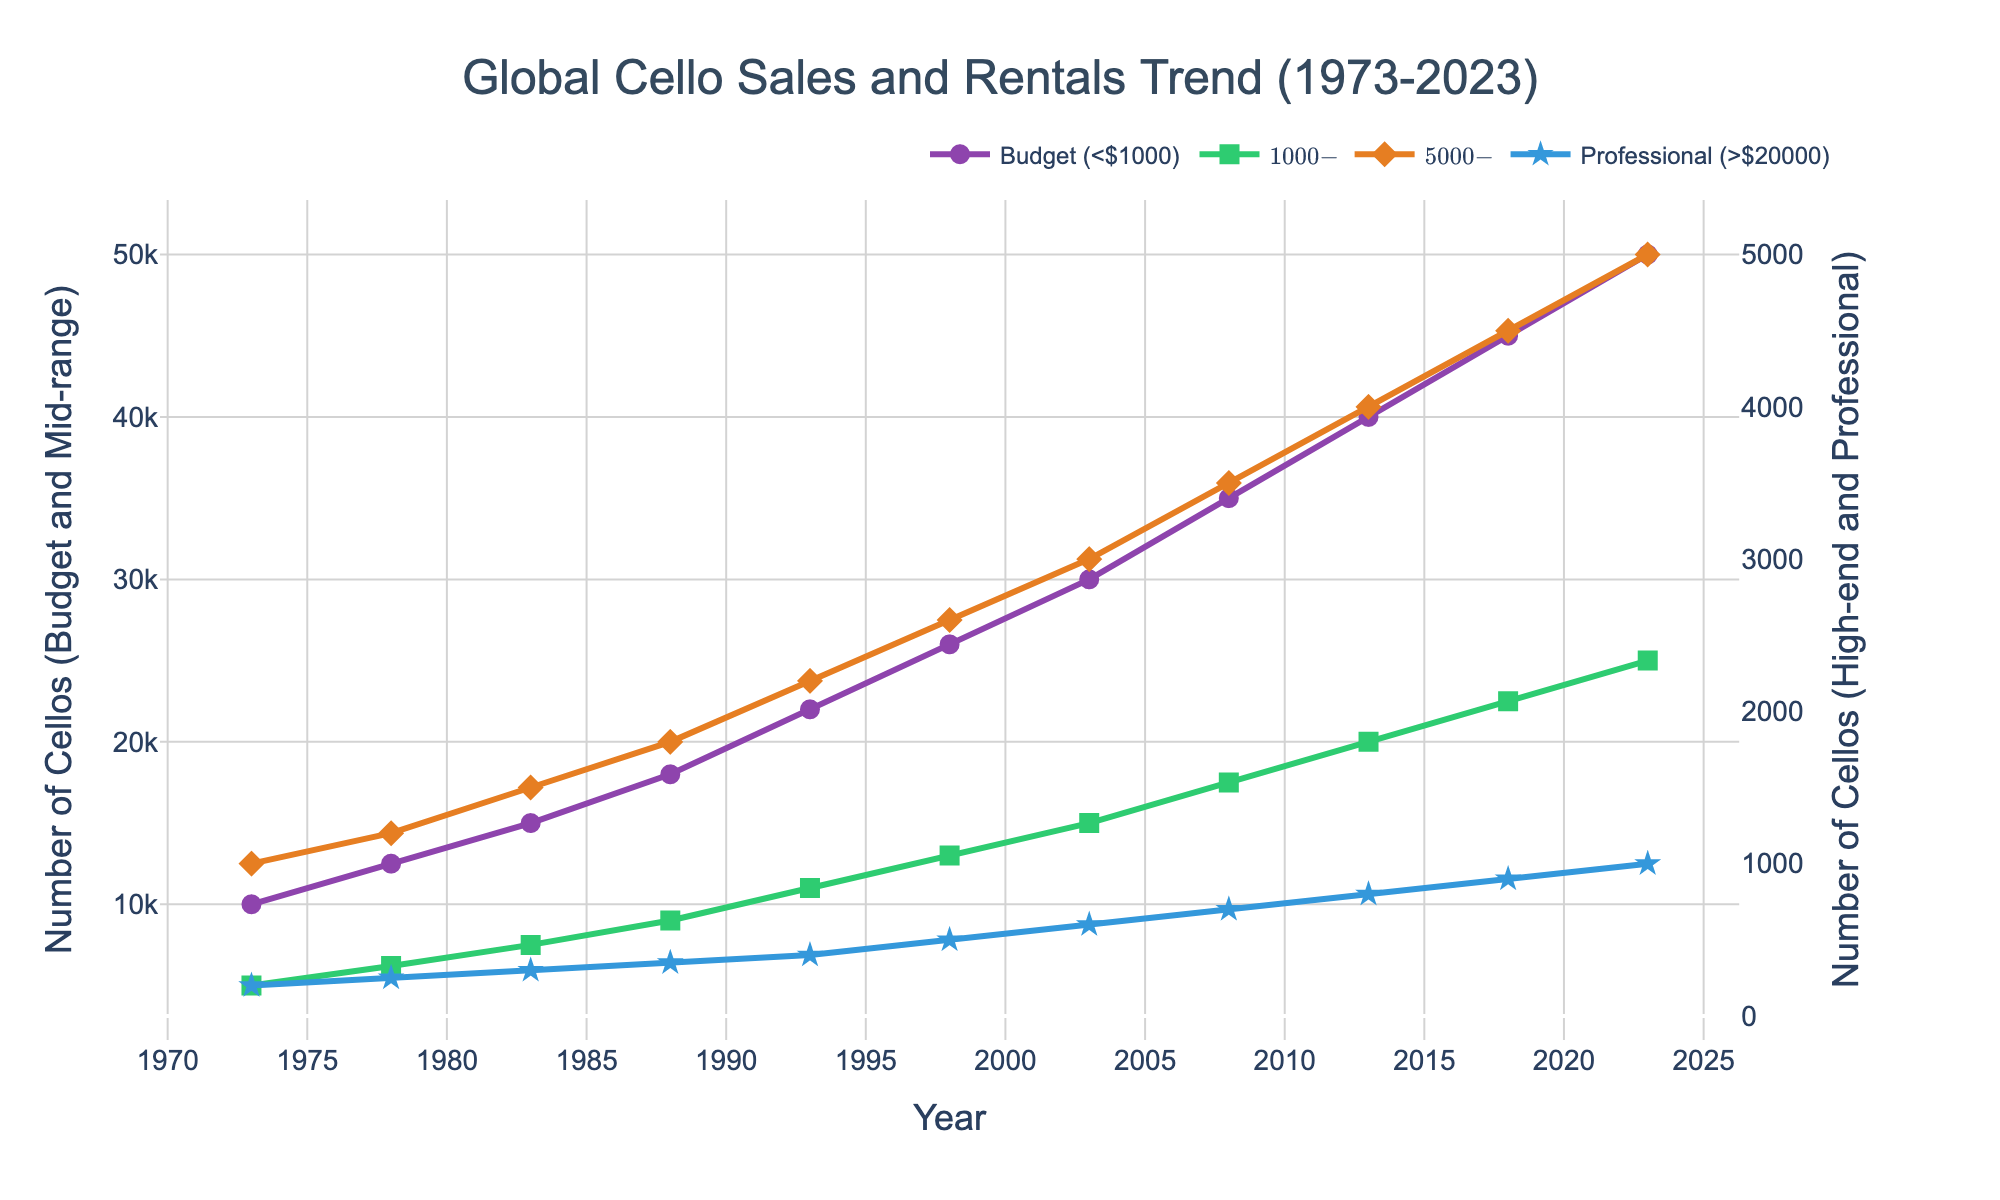How has the number of Budget cellos (under $1000) changed from 1973 to 2023? To find the change, note the Budget cellos (under $1000) sold/rented in 1973 and in 2023. Subtract the number in 1973 from the number in 2023: 50000 - 10000 = 40000
Answer: The number of Budget cellos has increased by 40,000 from 1973 to 2023 Which price range is represented by the green line in the chart, and how can you tell? The green line represents "Mid-range ($1000-$5000)" cellos. The line color in the legend is associated with the green lines, identifying the mid-range price category
Answer: Mid-range ($1000-$5000) Between which years did the number of Professional cellos (over $20000) increase the most? Review the changes in the Professional cellos' quantities tracked annually. The increase from 2018 to 2023 is from 900 to 1000, showing an increase of 100 units. Previous years show smaller increases
Answer: The greatest increase was between 2018 and 2023 Compare the growth trends of Budget and High-end cellos from 1973 to 2023. Look at the line trends for Budget (<$1000) and High-end ($5000-$20000) cellos. Budget cellos show a steep and consistent increase, while the High-end cellos have a more gradual slope. Both categories grow, but Budget cellos grow faster and to a higher number
Answer: Budget cellos grew more rapidly than High-end cellos What can be observed about the trend of sales and rentals of Mid-range cellos from 1988 to 2013? Examine the Mid-range ($1000-$5000) line between 1988 and 2013. The data shows a steady and consistent increase, from 9000 in 1988 to 20000 in 2013
Answer: A steady increase How do the sales trends of Mid-range and High-end cellos in 1998 compare? Compare the data points for 1998. Mid-range cellos are at 13000, and High-end cellos are at 2600. The Mid-range line is significantly higher
Answer: Mid-range sales are higher than High-end What is the trend for the number of Professional cellos from 2013 to 2023? Review the Professional (>$20000) cellos' data points from 2013 to 2023. The number increases from 800 in 2013 to 1000 in 2023, showing a steady upward trend
Answer: Increasing trend Which category has the highest initial quantity in 1973, and how can you tell? Compare the starting values in 1973. The Budget (<$1000) category starts at 10000, the highest initial number among all the price ranges
Answer: Budget (<$1000) What is the cumulative increase in the number of Mid-range (1000-$5000) cellos from 1973 to 2023? Compute the sum of increments over the years: 6200-5000 = 1200, 7500-6200 = 1300, 9000-7500 = 1500, 11000-9000 = 2000, 13000-11000 = 2000, 15000-13000 = 2000, 17500-15000 = 2500, 20000-17500 = 2500, 22500-20000 = 2500, 25000-22500 = 2500. Then total these increments: 1200+1300+1500+2000+2000+2000+2500+2500+2500+2500 = 22000
Answer: 22000 